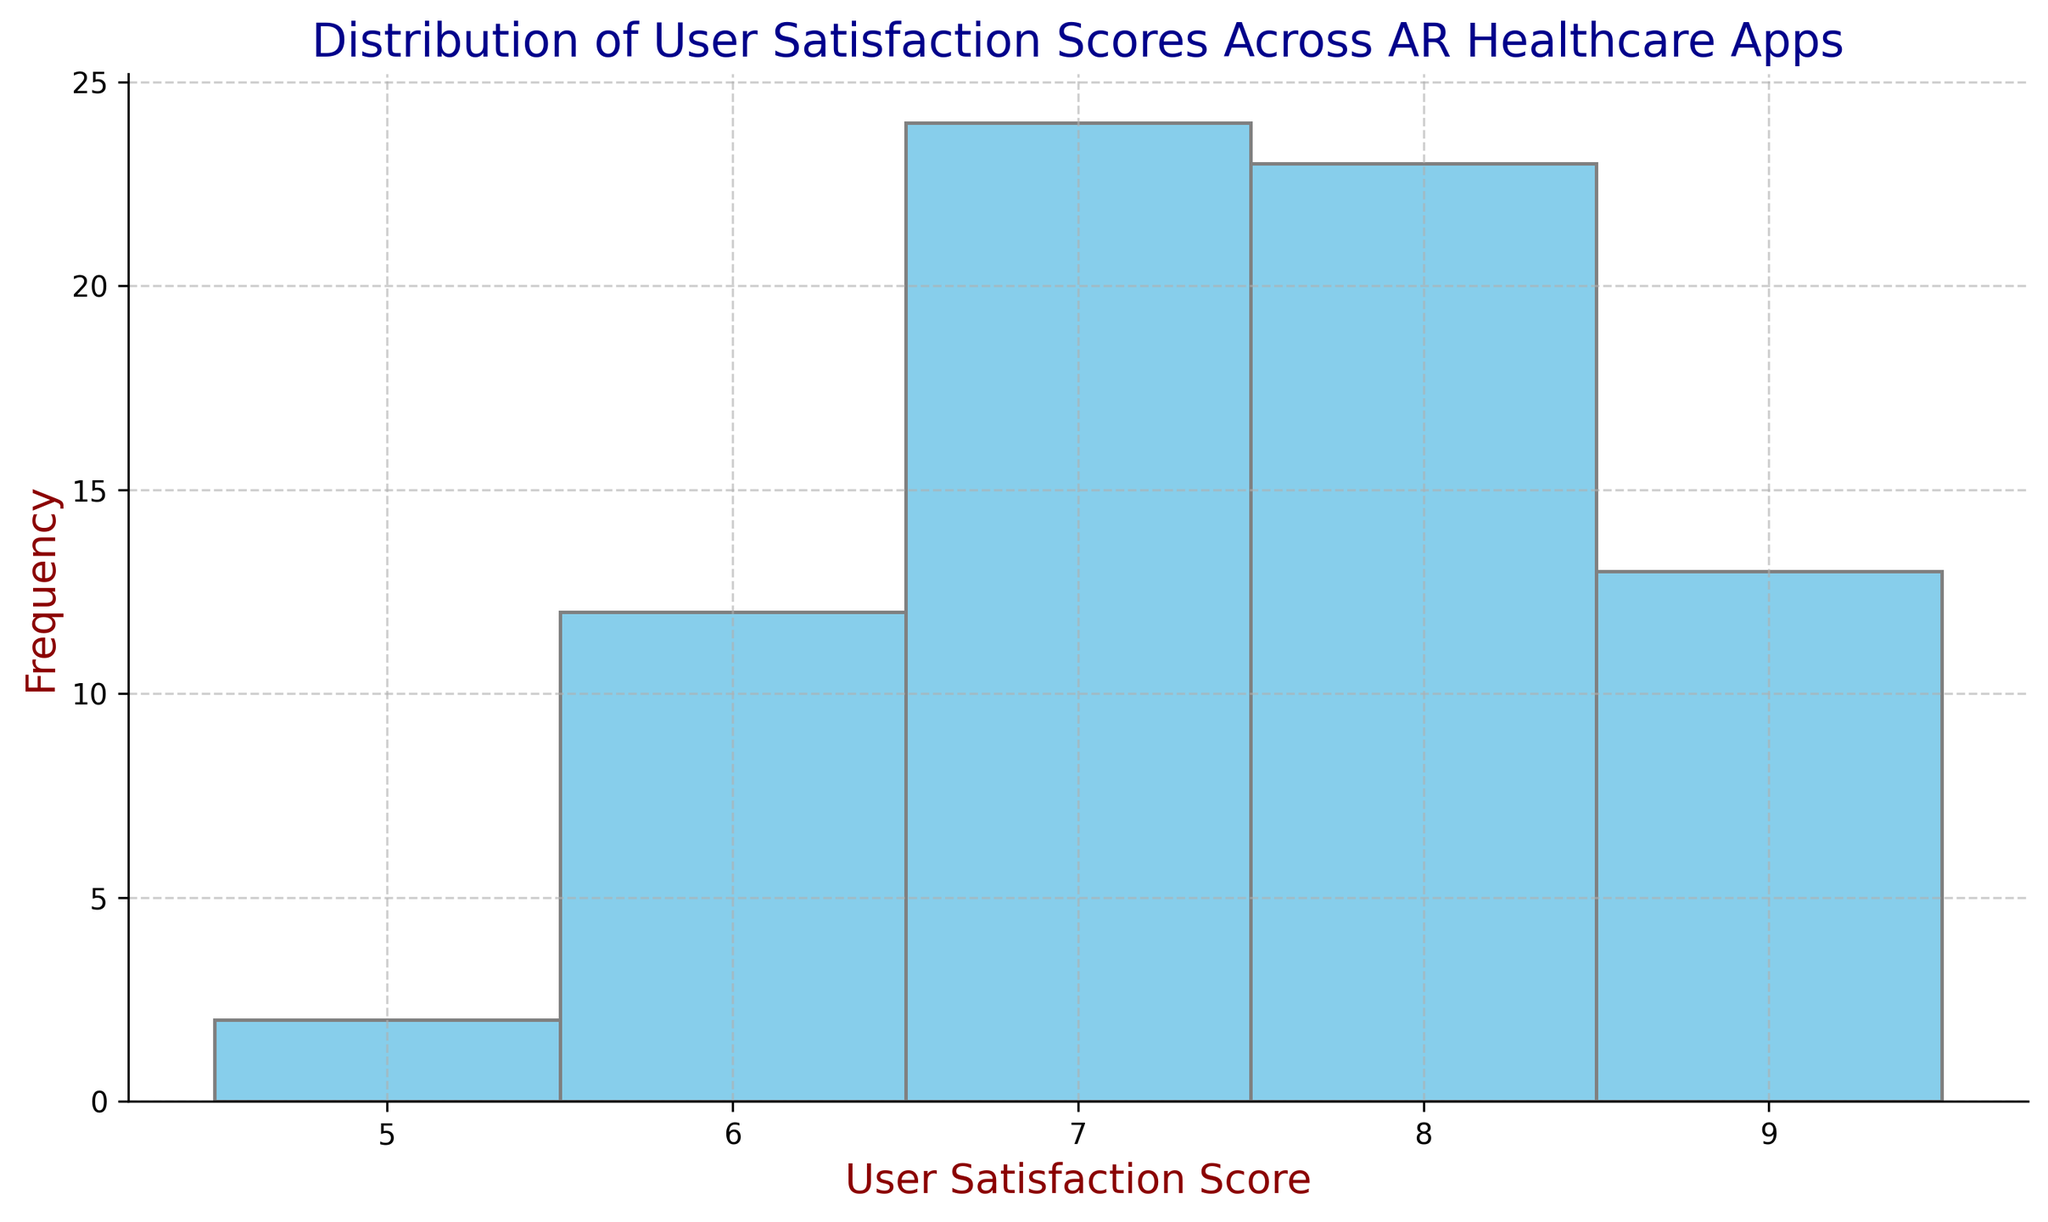Which user satisfaction score has the highest frequency? The histogram shows that the score with the highest bar (frequency) is 7.
Answer: 7 How many user satisfaction scores are there between 8 and 9, inclusive? To find the range from 8 to 9, check the frequency of the bars labeled 8 and 9 and sum them.
Answer: 29 What is the range of user satisfaction scores shown in the histogram? The histogram bins start at 5 and extend to 9, indicating the range of satisfaction scores.
Answer: 5 to 9 Which satisfaction score has the lowest frequency? The histogram shows the smallest bar (frequency); visually, the bar for the score 5 is the shortest.
Answer: 5 Is there a higher frequency of scores of 6 or 8? Compare the heights of the bars labeled 6 and 8; the bar for score 8 is taller.
Answer: 8 What is the frequency difference between the scores 7 and 9? Count the frequency of scores labeled 7 and 9 then subtract the smaller from the larger.
Answer: 7 Are there more users with satisfaction scores below 7 or above 7? Sum the frequencies of bars for scores below 7 and compare them to the sum of frequencies for scores above 7.
Answer: Above 7 What is the total frequency of user satisfaction scores represented in the histogram? Sum the frequencies of all the bins from 5 to 9.
Answer: 63 What score has the second highest frequency? Identify the frequency of each score and find the second largest value; visually, the bar for score 8 is the second tallest.
Answer: 8 